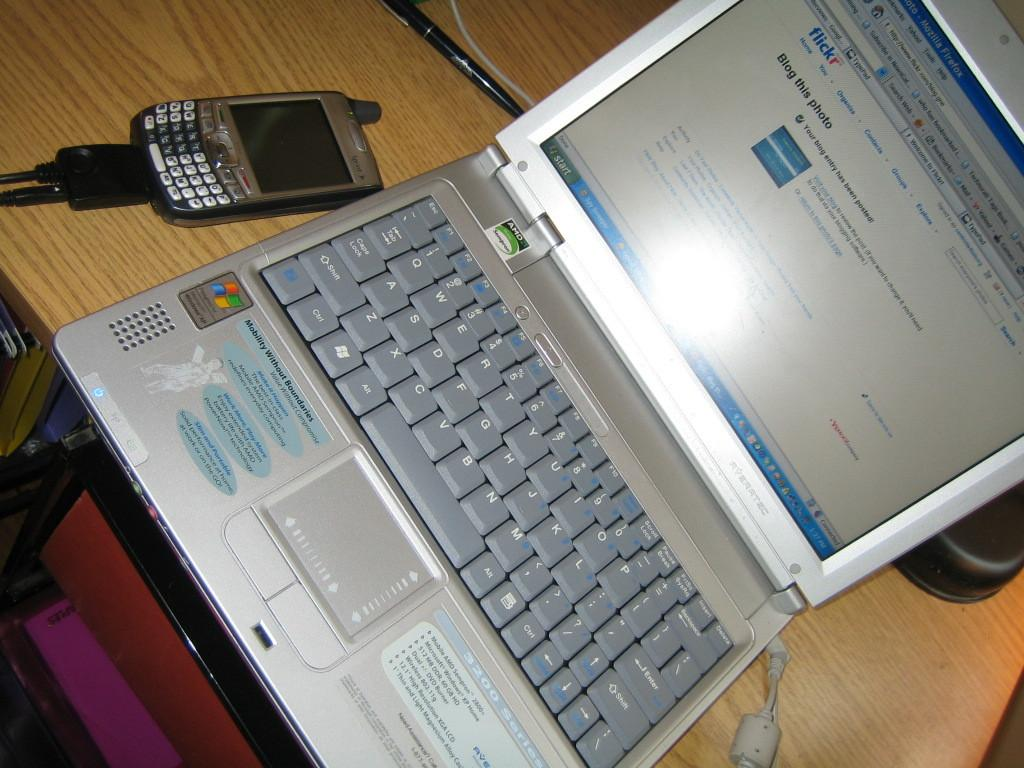Provide a one-sentence caption for the provided image. Blog this Photo on Flickr gives website visitors a way to bring energy to the image sharing site. 